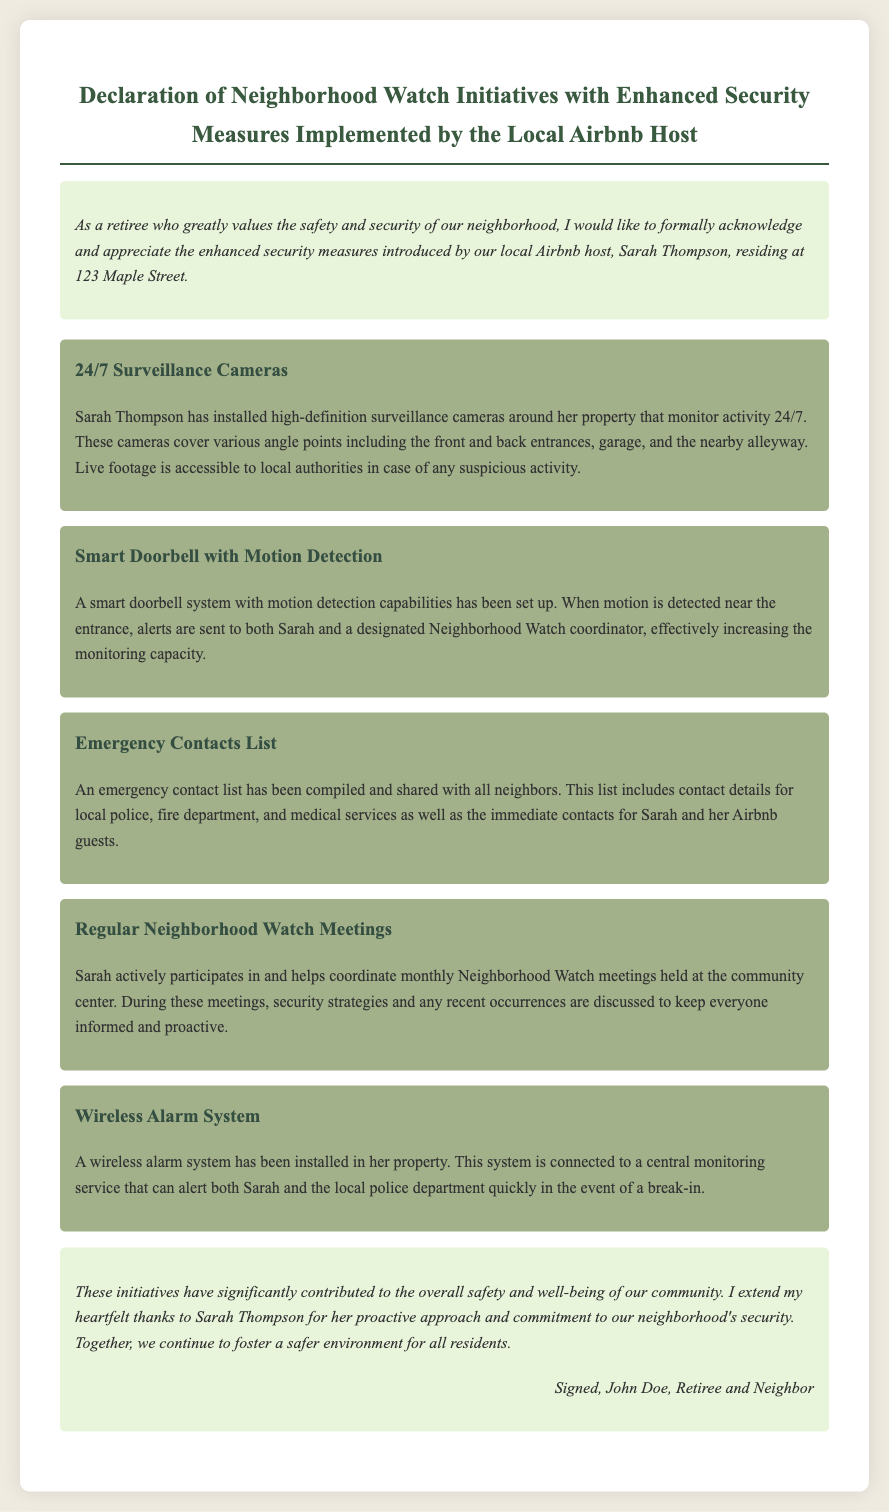What is the name of the local Airbnb host? The document mentions Sarah Thompson as the local Airbnb host at 123 Maple Street.
Answer: Sarah Thompson What type of surveillance system is installed? The document states that there are high-definition surveillance cameras monitoring activity around the property.
Answer: Surveillance cameras How often are Neighborhood Watch meetings held? The document indicates that the Neighborhood Watch meetings are held monthly.
Answer: Monthly What security feature sends alerts for motion detection? The document describes a smart doorbell with motion detection capabilities that sends alerts.
Answer: Smart doorbell Who signed the declaration? The declaration is signed by John Doe, who is a retiree and neighbor.
Answer: John Doe What is one of the emergency contacts included in the list? The document states that the emergency contacts list includes detail for local police.
Answer: Local police How does the wireless alarm system notify in case of a break-in? The document mentions that the wireless alarm system is connected to a central monitoring service that can alert Sarah and the police.
Answer: Central monitoring service What is the primary purpose of the initiatives mentioned in the document? The initiatives have been put in place to enhance the safety and security of the neighborhood.
Answer: Enhance safety and security Which specific location hosts the Neighborhood Watch meetings? The document indicates that the meetings are held at the community center.
Answer: Community center 